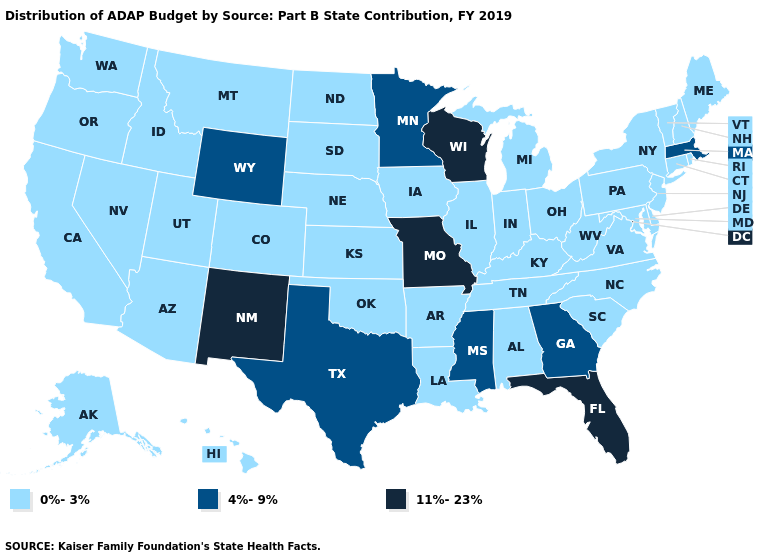What is the value of West Virginia?
Short answer required. 0%-3%. Name the states that have a value in the range 0%-3%?
Write a very short answer. Alabama, Alaska, Arizona, Arkansas, California, Colorado, Connecticut, Delaware, Hawaii, Idaho, Illinois, Indiana, Iowa, Kansas, Kentucky, Louisiana, Maine, Maryland, Michigan, Montana, Nebraska, Nevada, New Hampshire, New Jersey, New York, North Carolina, North Dakota, Ohio, Oklahoma, Oregon, Pennsylvania, Rhode Island, South Carolina, South Dakota, Tennessee, Utah, Vermont, Virginia, Washington, West Virginia. Does the first symbol in the legend represent the smallest category?
Keep it brief. Yes. Name the states that have a value in the range 11%-23%?
Answer briefly. Florida, Missouri, New Mexico, Wisconsin. What is the lowest value in states that border North Dakota?
Give a very brief answer. 0%-3%. Does Indiana have the lowest value in the MidWest?
Give a very brief answer. Yes. Is the legend a continuous bar?
Give a very brief answer. No. What is the highest value in the MidWest ?
Keep it brief. 11%-23%. Name the states that have a value in the range 4%-9%?
Write a very short answer. Georgia, Massachusetts, Minnesota, Mississippi, Texas, Wyoming. Name the states that have a value in the range 0%-3%?
Answer briefly. Alabama, Alaska, Arizona, Arkansas, California, Colorado, Connecticut, Delaware, Hawaii, Idaho, Illinois, Indiana, Iowa, Kansas, Kentucky, Louisiana, Maine, Maryland, Michigan, Montana, Nebraska, Nevada, New Hampshire, New Jersey, New York, North Carolina, North Dakota, Ohio, Oklahoma, Oregon, Pennsylvania, Rhode Island, South Carolina, South Dakota, Tennessee, Utah, Vermont, Virginia, Washington, West Virginia. What is the value of Hawaii?
Short answer required. 0%-3%. Does South Carolina have a higher value than Montana?
Give a very brief answer. No. What is the highest value in the USA?
Give a very brief answer. 11%-23%. Does Minnesota have the lowest value in the MidWest?
Give a very brief answer. No. What is the value of Oregon?
Short answer required. 0%-3%. 